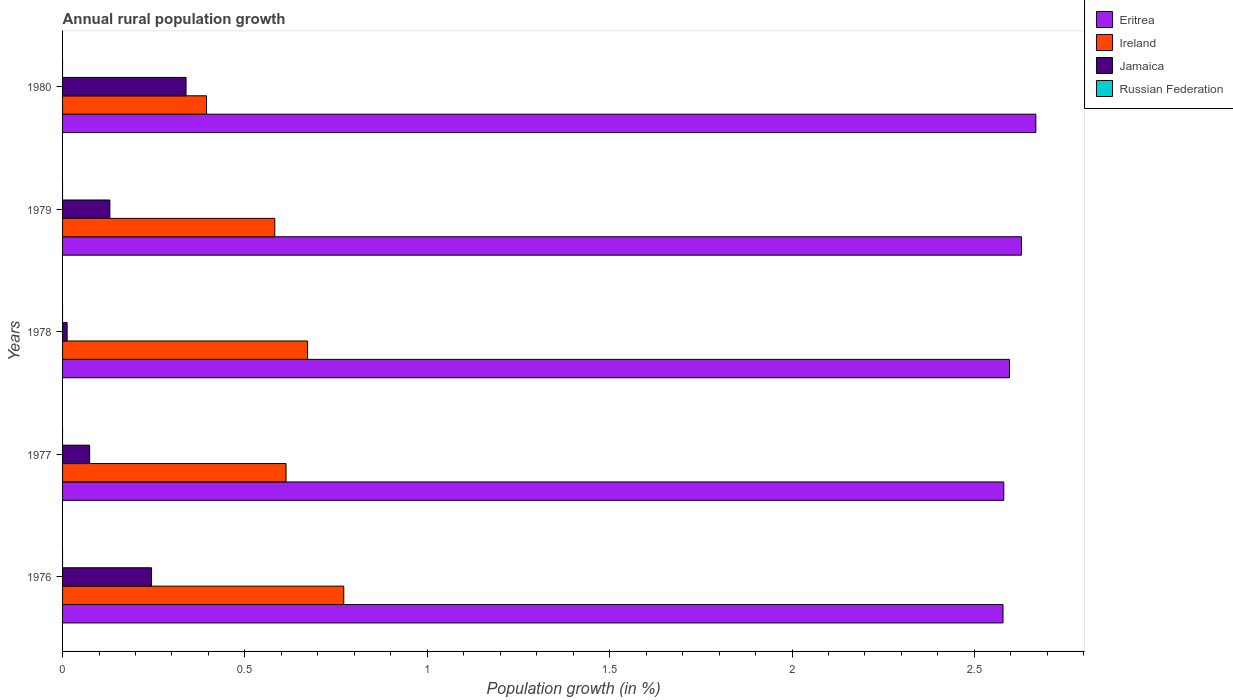Are the number of bars on each tick of the Y-axis equal?
Give a very brief answer. Yes. How many bars are there on the 1st tick from the top?
Your response must be concise. 3. How many bars are there on the 3rd tick from the bottom?
Offer a terse response. 3. What is the label of the 4th group of bars from the top?
Give a very brief answer. 1977. In how many cases, is the number of bars for a given year not equal to the number of legend labels?
Offer a terse response. 5. Across all years, what is the maximum percentage of rural population growth in Jamaica?
Provide a succinct answer. 0.34. Across all years, what is the minimum percentage of rural population growth in Jamaica?
Ensure brevity in your answer.  0.01. What is the total percentage of rural population growth in Jamaica in the graph?
Provide a succinct answer. 0.8. What is the difference between the percentage of rural population growth in Jamaica in 1976 and that in 1980?
Offer a very short reply. -0.09. What is the difference between the percentage of rural population growth in Eritrea in 1980 and the percentage of rural population growth in Ireland in 1977?
Give a very brief answer. 2.06. What is the average percentage of rural population growth in Eritrea per year?
Your answer should be compact. 2.61. In the year 1978, what is the difference between the percentage of rural population growth in Eritrea and percentage of rural population growth in Jamaica?
Offer a terse response. 2.58. In how many years, is the percentage of rural population growth in Russian Federation greater than 1 %?
Offer a very short reply. 0. What is the ratio of the percentage of rural population growth in Jamaica in 1976 to that in 1979?
Give a very brief answer. 1.88. Is the difference between the percentage of rural population growth in Eritrea in 1976 and 1977 greater than the difference between the percentage of rural population growth in Jamaica in 1976 and 1977?
Your response must be concise. No. What is the difference between the highest and the second highest percentage of rural population growth in Ireland?
Your answer should be very brief. 0.1. What is the difference between the highest and the lowest percentage of rural population growth in Jamaica?
Make the answer very short. 0.33. Is the sum of the percentage of rural population growth in Jamaica in 1977 and 1978 greater than the maximum percentage of rural population growth in Ireland across all years?
Your answer should be very brief. No. Is it the case that in every year, the sum of the percentage of rural population growth in Eritrea and percentage of rural population growth in Russian Federation is greater than the sum of percentage of rural population growth in Jamaica and percentage of rural population growth in Ireland?
Provide a succinct answer. Yes. How many years are there in the graph?
Make the answer very short. 5. What is the difference between two consecutive major ticks on the X-axis?
Ensure brevity in your answer.  0.5. Are the values on the major ticks of X-axis written in scientific E-notation?
Keep it short and to the point. No. How many legend labels are there?
Ensure brevity in your answer.  4. What is the title of the graph?
Provide a short and direct response. Annual rural population growth. Does "Mongolia" appear as one of the legend labels in the graph?
Provide a short and direct response. No. What is the label or title of the X-axis?
Offer a terse response. Population growth (in %). What is the label or title of the Y-axis?
Make the answer very short. Years. What is the Population growth (in %) of Eritrea in 1976?
Offer a very short reply. 2.58. What is the Population growth (in %) in Ireland in 1976?
Give a very brief answer. 0.77. What is the Population growth (in %) in Jamaica in 1976?
Keep it short and to the point. 0.24. What is the Population growth (in %) of Eritrea in 1977?
Offer a very short reply. 2.58. What is the Population growth (in %) of Ireland in 1977?
Ensure brevity in your answer.  0.61. What is the Population growth (in %) in Jamaica in 1977?
Offer a terse response. 0.07. What is the Population growth (in %) in Eritrea in 1978?
Keep it short and to the point. 2.6. What is the Population growth (in %) in Ireland in 1978?
Your answer should be very brief. 0.67. What is the Population growth (in %) in Jamaica in 1978?
Your answer should be compact. 0.01. What is the Population growth (in %) of Russian Federation in 1978?
Your answer should be very brief. 0. What is the Population growth (in %) of Eritrea in 1979?
Offer a terse response. 2.63. What is the Population growth (in %) of Ireland in 1979?
Ensure brevity in your answer.  0.58. What is the Population growth (in %) of Jamaica in 1979?
Ensure brevity in your answer.  0.13. What is the Population growth (in %) of Eritrea in 1980?
Provide a short and direct response. 2.67. What is the Population growth (in %) in Ireland in 1980?
Make the answer very short. 0.39. What is the Population growth (in %) in Jamaica in 1980?
Provide a succinct answer. 0.34. Across all years, what is the maximum Population growth (in %) of Eritrea?
Ensure brevity in your answer.  2.67. Across all years, what is the maximum Population growth (in %) in Ireland?
Your answer should be compact. 0.77. Across all years, what is the maximum Population growth (in %) of Jamaica?
Provide a succinct answer. 0.34. Across all years, what is the minimum Population growth (in %) in Eritrea?
Your answer should be very brief. 2.58. Across all years, what is the minimum Population growth (in %) in Ireland?
Your answer should be compact. 0.39. Across all years, what is the minimum Population growth (in %) of Jamaica?
Keep it short and to the point. 0.01. What is the total Population growth (in %) of Eritrea in the graph?
Offer a terse response. 13.05. What is the total Population growth (in %) of Ireland in the graph?
Provide a short and direct response. 3.03. What is the total Population growth (in %) in Jamaica in the graph?
Provide a short and direct response. 0.8. What is the difference between the Population growth (in %) in Eritrea in 1976 and that in 1977?
Your answer should be compact. -0. What is the difference between the Population growth (in %) in Ireland in 1976 and that in 1977?
Keep it short and to the point. 0.16. What is the difference between the Population growth (in %) in Jamaica in 1976 and that in 1977?
Keep it short and to the point. 0.17. What is the difference between the Population growth (in %) in Eritrea in 1976 and that in 1978?
Keep it short and to the point. -0.02. What is the difference between the Population growth (in %) in Ireland in 1976 and that in 1978?
Your response must be concise. 0.1. What is the difference between the Population growth (in %) in Jamaica in 1976 and that in 1978?
Keep it short and to the point. 0.23. What is the difference between the Population growth (in %) in Eritrea in 1976 and that in 1979?
Provide a short and direct response. -0.05. What is the difference between the Population growth (in %) in Ireland in 1976 and that in 1979?
Your answer should be very brief. 0.19. What is the difference between the Population growth (in %) in Jamaica in 1976 and that in 1979?
Give a very brief answer. 0.11. What is the difference between the Population growth (in %) in Eritrea in 1976 and that in 1980?
Your answer should be very brief. -0.09. What is the difference between the Population growth (in %) in Ireland in 1976 and that in 1980?
Make the answer very short. 0.38. What is the difference between the Population growth (in %) of Jamaica in 1976 and that in 1980?
Provide a succinct answer. -0.09. What is the difference between the Population growth (in %) in Eritrea in 1977 and that in 1978?
Offer a terse response. -0.02. What is the difference between the Population growth (in %) of Ireland in 1977 and that in 1978?
Ensure brevity in your answer.  -0.06. What is the difference between the Population growth (in %) of Jamaica in 1977 and that in 1978?
Ensure brevity in your answer.  0.06. What is the difference between the Population growth (in %) in Eritrea in 1977 and that in 1979?
Provide a short and direct response. -0.05. What is the difference between the Population growth (in %) of Ireland in 1977 and that in 1979?
Keep it short and to the point. 0.03. What is the difference between the Population growth (in %) in Jamaica in 1977 and that in 1979?
Your answer should be compact. -0.06. What is the difference between the Population growth (in %) in Eritrea in 1977 and that in 1980?
Provide a short and direct response. -0.09. What is the difference between the Population growth (in %) in Ireland in 1977 and that in 1980?
Offer a terse response. 0.22. What is the difference between the Population growth (in %) of Jamaica in 1977 and that in 1980?
Offer a terse response. -0.26. What is the difference between the Population growth (in %) in Eritrea in 1978 and that in 1979?
Offer a terse response. -0.03. What is the difference between the Population growth (in %) of Ireland in 1978 and that in 1979?
Give a very brief answer. 0.09. What is the difference between the Population growth (in %) of Jamaica in 1978 and that in 1979?
Your answer should be compact. -0.12. What is the difference between the Population growth (in %) in Eritrea in 1978 and that in 1980?
Give a very brief answer. -0.07. What is the difference between the Population growth (in %) in Ireland in 1978 and that in 1980?
Provide a short and direct response. 0.28. What is the difference between the Population growth (in %) of Jamaica in 1978 and that in 1980?
Ensure brevity in your answer.  -0.33. What is the difference between the Population growth (in %) of Eritrea in 1979 and that in 1980?
Make the answer very short. -0.04. What is the difference between the Population growth (in %) in Ireland in 1979 and that in 1980?
Your answer should be compact. 0.19. What is the difference between the Population growth (in %) in Jamaica in 1979 and that in 1980?
Provide a short and direct response. -0.21. What is the difference between the Population growth (in %) in Eritrea in 1976 and the Population growth (in %) in Ireland in 1977?
Ensure brevity in your answer.  1.97. What is the difference between the Population growth (in %) of Eritrea in 1976 and the Population growth (in %) of Jamaica in 1977?
Your answer should be very brief. 2.5. What is the difference between the Population growth (in %) of Ireland in 1976 and the Population growth (in %) of Jamaica in 1977?
Keep it short and to the point. 0.7. What is the difference between the Population growth (in %) of Eritrea in 1976 and the Population growth (in %) of Ireland in 1978?
Keep it short and to the point. 1.91. What is the difference between the Population growth (in %) of Eritrea in 1976 and the Population growth (in %) of Jamaica in 1978?
Provide a succinct answer. 2.57. What is the difference between the Population growth (in %) in Ireland in 1976 and the Population growth (in %) in Jamaica in 1978?
Make the answer very short. 0.76. What is the difference between the Population growth (in %) of Eritrea in 1976 and the Population growth (in %) of Ireland in 1979?
Provide a succinct answer. 2. What is the difference between the Population growth (in %) of Eritrea in 1976 and the Population growth (in %) of Jamaica in 1979?
Ensure brevity in your answer.  2.45. What is the difference between the Population growth (in %) in Ireland in 1976 and the Population growth (in %) in Jamaica in 1979?
Keep it short and to the point. 0.64. What is the difference between the Population growth (in %) of Eritrea in 1976 and the Population growth (in %) of Ireland in 1980?
Keep it short and to the point. 2.18. What is the difference between the Population growth (in %) of Eritrea in 1976 and the Population growth (in %) of Jamaica in 1980?
Provide a short and direct response. 2.24. What is the difference between the Population growth (in %) in Ireland in 1976 and the Population growth (in %) in Jamaica in 1980?
Provide a short and direct response. 0.43. What is the difference between the Population growth (in %) in Eritrea in 1977 and the Population growth (in %) in Ireland in 1978?
Provide a succinct answer. 1.91. What is the difference between the Population growth (in %) of Eritrea in 1977 and the Population growth (in %) of Jamaica in 1978?
Offer a terse response. 2.57. What is the difference between the Population growth (in %) of Ireland in 1977 and the Population growth (in %) of Jamaica in 1978?
Your answer should be very brief. 0.6. What is the difference between the Population growth (in %) of Eritrea in 1977 and the Population growth (in %) of Ireland in 1979?
Make the answer very short. 2. What is the difference between the Population growth (in %) in Eritrea in 1977 and the Population growth (in %) in Jamaica in 1979?
Make the answer very short. 2.45. What is the difference between the Population growth (in %) of Ireland in 1977 and the Population growth (in %) of Jamaica in 1979?
Your response must be concise. 0.48. What is the difference between the Population growth (in %) in Eritrea in 1977 and the Population growth (in %) in Ireland in 1980?
Give a very brief answer. 2.19. What is the difference between the Population growth (in %) in Eritrea in 1977 and the Population growth (in %) in Jamaica in 1980?
Offer a very short reply. 2.24. What is the difference between the Population growth (in %) in Ireland in 1977 and the Population growth (in %) in Jamaica in 1980?
Keep it short and to the point. 0.27. What is the difference between the Population growth (in %) in Eritrea in 1978 and the Population growth (in %) in Ireland in 1979?
Ensure brevity in your answer.  2.01. What is the difference between the Population growth (in %) in Eritrea in 1978 and the Population growth (in %) in Jamaica in 1979?
Your answer should be compact. 2.47. What is the difference between the Population growth (in %) of Ireland in 1978 and the Population growth (in %) of Jamaica in 1979?
Make the answer very short. 0.54. What is the difference between the Population growth (in %) of Eritrea in 1978 and the Population growth (in %) of Ireland in 1980?
Provide a succinct answer. 2.2. What is the difference between the Population growth (in %) of Eritrea in 1978 and the Population growth (in %) of Jamaica in 1980?
Provide a succinct answer. 2.26. What is the difference between the Population growth (in %) of Ireland in 1978 and the Population growth (in %) of Jamaica in 1980?
Keep it short and to the point. 0.33. What is the difference between the Population growth (in %) of Eritrea in 1979 and the Population growth (in %) of Ireland in 1980?
Provide a succinct answer. 2.23. What is the difference between the Population growth (in %) of Eritrea in 1979 and the Population growth (in %) of Jamaica in 1980?
Your answer should be very brief. 2.29. What is the difference between the Population growth (in %) in Ireland in 1979 and the Population growth (in %) in Jamaica in 1980?
Your answer should be very brief. 0.24. What is the average Population growth (in %) of Eritrea per year?
Ensure brevity in your answer.  2.61. What is the average Population growth (in %) of Ireland per year?
Offer a terse response. 0.61. What is the average Population growth (in %) in Jamaica per year?
Your answer should be very brief. 0.16. What is the average Population growth (in %) of Russian Federation per year?
Give a very brief answer. 0. In the year 1976, what is the difference between the Population growth (in %) of Eritrea and Population growth (in %) of Ireland?
Provide a succinct answer. 1.81. In the year 1976, what is the difference between the Population growth (in %) of Eritrea and Population growth (in %) of Jamaica?
Make the answer very short. 2.33. In the year 1976, what is the difference between the Population growth (in %) of Ireland and Population growth (in %) of Jamaica?
Provide a short and direct response. 0.53. In the year 1977, what is the difference between the Population growth (in %) in Eritrea and Population growth (in %) in Ireland?
Ensure brevity in your answer.  1.97. In the year 1977, what is the difference between the Population growth (in %) in Eritrea and Population growth (in %) in Jamaica?
Ensure brevity in your answer.  2.51. In the year 1977, what is the difference between the Population growth (in %) of Ireland and Population growth (in %) of Jamaica?
Your answer should be compact. 0.54. In the year 1978, what is the difference between the Population growth (in %) in Eritrea and Population growth (in %) in Ireland?
Keep it short and to the point. 1.92. In the year 1978, what is the difference between the Population growth (in %) in Eritrea and Population growth (in %) in Jamaica?
Your answer should be very brief. 2.58. In the year 1978, what is the difference between the Population growth (in %) of Ireland and Population growth (in %) of Jamaica?
Your response must be concise. 0.66. In the year 1979, what is the difference between the Population growth (in %) of Eritrea and Population growth (in %) of Ireland?
Your answer should be compact. 2.05. In the year 1979, what is the difference between the Population growth (in %) in Eritrea and Population growth (in %) in Jamaica?
Give a very brief answer. 2.5. In the year 1979, what is the difference between the Population growth (in %) in Ireland and Population growth (in %) in Jamaica?
Your response must be concise. 0.45. In the year 1980, what is the difference between the Population growth (in %) in Eritrea and Population growth (in %) in Ireland?
Give a very brief answer. 2.27. In the year 1980, what is the difference between the Population growth (in %) of Eritrea and Population growth (in %) of Jamaica?
Your answer should be very brief. 2.33. In the year 1980, what is the difference between the Population growth (in %) of Ireland and Population growth (in %) of Jamaica?
Provide a short and direct response. 0.06. What is the ratio of the Population growth (in %) of Eritrea in 1976 to that in 1977?
Offer a very short reply. 1. What is the ratio of the Population growth (in %) of Ireland in 1976 to that in 1977?
Your response must be concise. 1.26. What is the ratio of the Population growth (in %) in Jamaica in 1976 to that in 1977?
Your answer should be compact. 3.29. What is the ratio of the Population growth (in %) of Ireland in 1976 to that in 1978?
Your answer should be compact. 1.15. What is the ratio of the Population growth (in %) of Jamaica in 1976 to that in 1978?
Make the answer very short. 19.56. What is the ratio of the Population growth (in %) of Eritrea in 1976 to that in 1979?
Your answer should be compact. 0.98. What is the ratio of the Population growth (in %) in Ireland in 1976 to that in 1979?
Your answer should be very brief. 1.32. What is the ratio of the Population growth (in %) of Jamaica in 1976 to that in 1979?
Offer a very short reply. 1.88. What is the ratio of the Population growth (in %) of Eritrea in 1976 to that in 1980?
Provide a short and direct response. 0.97. What is the ratio of the Population growth (in %) of Ireland in 1976 to that in 1980?
Provide a short and direct response. 1.95. What is the ratio of the Population growth (in %) in Jamaica in 1976 to that in 1980?
Make the answer very short. 0.72. What is the ratio of the Population growth (in %) in Eritrea in 1977 to that in 1978?
Give a very brief answer. 0.99. What is the ratio of the Population growth (in %) in Ireland in 1977 to that in 1978?
Ensure brevity in your answer.  0.91. What is the ratio of the Population growth (in %) of Jamaica in 1977 to that in 1978?
Your response must be concise. 5.95. What is the ratio of the Population growth (in %) in Eritrea in 1977 to that in 1979?
Your answer should be compact. 0.98. What is the ratio of the Population growth (in %) of Ireland in 1977 to that in 1979?
Make the answer very short. 1.05. What is the ratio of the Population growth (in %) of Jamaica in 1977 to that in 1979?
Offer a terse response. 0.57. What is the ratio of the Population growth (in %) in Eritrea in 1977 to that in 1980?
Your response must be concise. 0.97. What is the ratio of the Population growth (in %) in Ireland in 1977 to that in 1980?
Offer a very short reply. 1.55. What is the ratio of the Population growth (in %) in Jamaica in 1977 to that in 1980?
Offer a very short reply. 0.22. What is the ratio of the Population growth (in %) of Eritrea in 1978 to that in 1979?
Your answer should be compact. 0.99. What is the ratio of the Population growth (in %) in Ireland in 1978 to that in 1979?
Make the answer very short. 1.15. What is the ratio of the Population growth (in %) in Jamaica in 1978 to that in 1979?
Ensure brevity in your answer.  0.1. What is the ratio of the Population growth (in %) of Eritrea in 1978 to that in 1980?
Ensure brevity in your answer.  0.97. What is the ratio of the Population growth (in %) of Ireland in 1978 to that in 1980?
Your response must be concise. 1.7. What is the ratio of the Population growth (in %) in Jamaica in 1978 to that in 1980?
Give a very brief answer. 0.04. What is the ratio of the Population growth (in %) in Eritrea in 1979 to that in 1980?
Your answer should be very brief. 0.99. What is the ratio of the Population growth (in %) in Ireland in 1979 to that in 1980?
Give a very brief answer. 1.47. What is the ratio of the Population growth (in %) in Jamaica in 1979 to that in 1980?
Provide a short and direct response. 0.38. What is the difference between the highest and the second highest Population growth (in %) of Eritrea?
Provide a succinct answer. 0.04. What is the difference between the highest and the second highest Population growth (in %) in Ireland?
Keep it short and to the point. 0.1. What is the difference between the highest and the second highest Population growth (in %) of Jamaica?
Your response must be concise. 0.09. What is the difference between the highest and the lowest Population growth (in %) of Eritrea?
Provide a short and direct response. 0.09. What is the difference between the highest and the lowest Population growth (in %) of Ireland?
Ensure brevity in your answer.  0.38. What is the difference between the highest and the lowest Population growth (in %) in Jamaica?
Give a very brief answer. 0.33. 